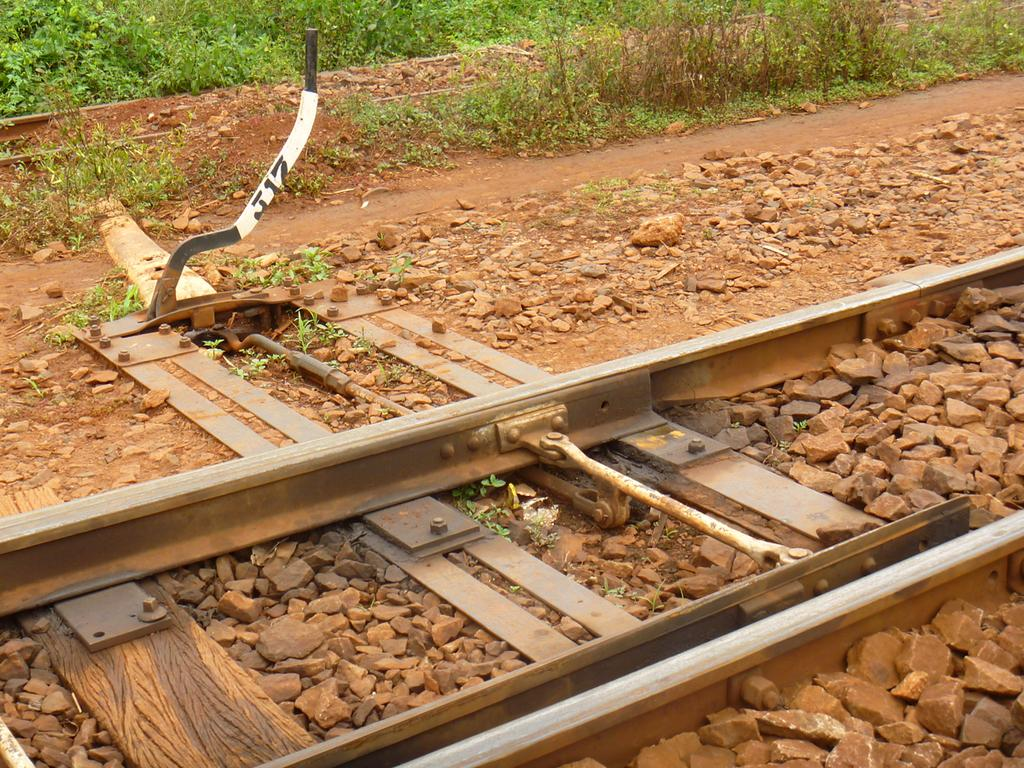What type of transportation infrastructure is present in the image? There is a railway track in the image. What type of natural elements can be seen in the image? There are stones, grass, and plants visible in the image. What is the ground surface like in the image? The ground is visible in the image. Can you see any trays carrying food on the railway track in the image? There are no trays carrying food visible on the railway track in the image. Is there any spark visible near the railway track in the image? There is no spark visible near the railway track in the image. How many ladybugs can be seen on the plants in the image? There are no ladybugs visible on the plants in the image. 